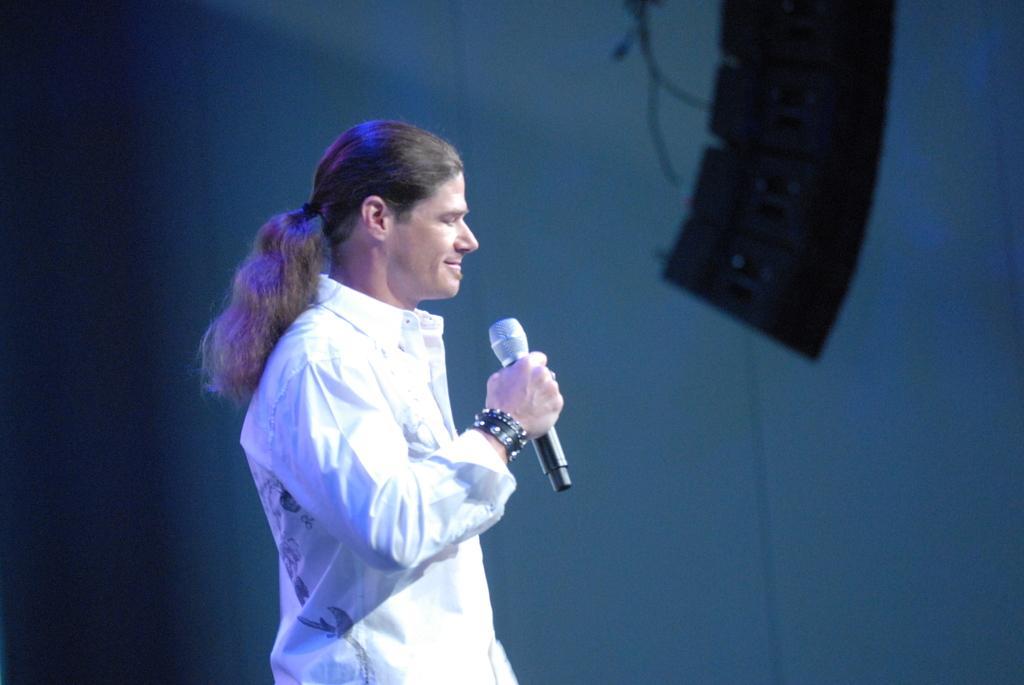Could you give a brief overview of what you see in this image? In this image a person wearing a white color shirt holding a microphone and there are bands around his wrist and at the right side of the image there is a DJ box and at the background it is a blue color sheet. 